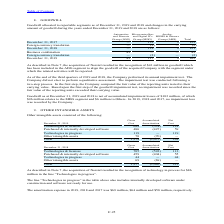According to Stmicroelectronics's financial document, How many million did the acquisition of Norstel contributed to goodwill? According to the financial document, $43 million. The relevant text states: "uisition of Norstel resulted in the recognition of $43 million in goodwill which has been included in the ADG segment to align the goodwill of the acquired Company..." Also, What are the steps included in the impairment test? In the first step, the Company compared the fair value of the reporting units tested to their carrying value. Based upon the first step of the goodwill impairment test, no impairment was recorded since the fair value of the reporting units exceeded their carrying value.. The document states: "t test was conducted following a two-step process. In the first step, the Company compared the fair value of the reporting units tested to their carry..." Also, How much no impairment loss was recorded by the Company in 2019, 2018 and 2017? In 2019, 2018 and 2017, no impairment loss was recorded by the Company.. The document states: "lates to the MDG segment and $6 million to Others. In 2019, 2018 and 2017, no impairment loss was recorded by the Company...." Also, can you calculate: What is the average goodwill for the period December 31, 2017? Based on the calculation: 123 / 2, the result is 61.5 (in millions). This is based on the information: "December 31, 2017 — 121 2 123 December 31, 2017 — 121 2 123..." The key data points involved are: 123, 2. Also, can you calculate: What is the average goodwill for the period December 31, 2018? Based on the calculation: 121 / 2, the result is 60.5 (in millions). This is based on the information: "December 31, 2017 — 121 2 123 December 31, 2017 — 121 2 123..." The key data points involved are: 121, 2. Also, can you calculate: What is the average goodwill for the period December 31, 2019? Based on the calculation: 162/ 3, the result is 54 (in millions). This is based on the information: "December 31, 2019 43 117 2 162 December 31, 2019 43 117 2 162..." The key data points involved are: 162, 3. 